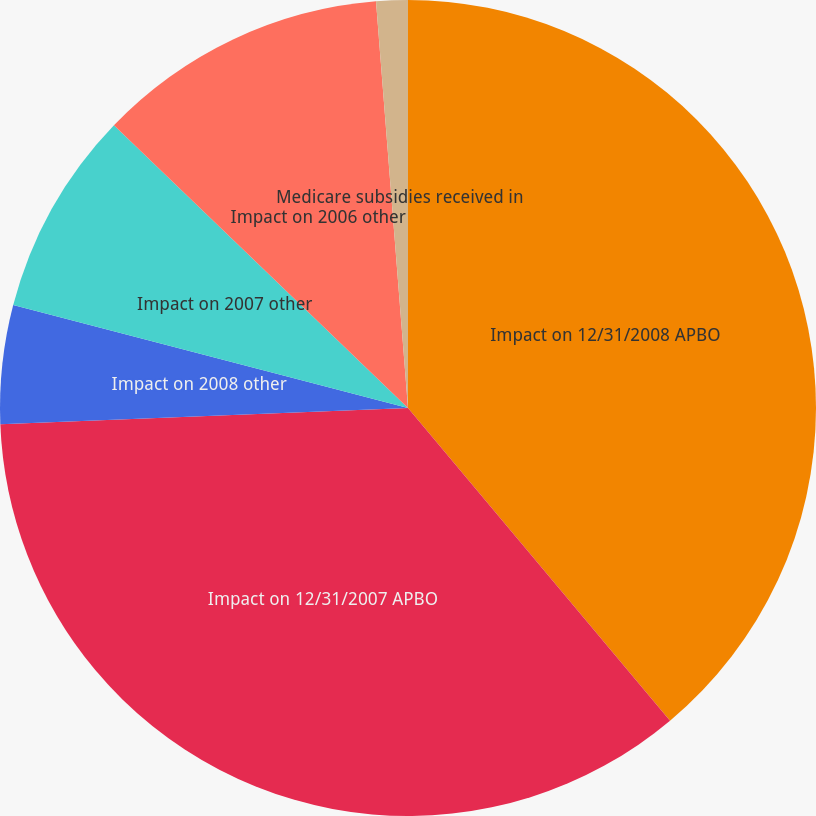Convert chart. <chart><loc_0><loc_0><loc_500><loc_500><pie_chart><fcel>Impact on 12/31/2008 APBO<fcel>Impact on 12/31/2007 APBO<fcel>Impact on 2008 other<fcel>Impact on 2007 other<fcel>Impact on 2006 other<fcel>Medicare subsidies received in<nl><fcel>38.9%<fcel>35.47%<fcel>4.69%<fcel>8.13%<fcel>11.56%<fcel>1.25%<nl></chart> 